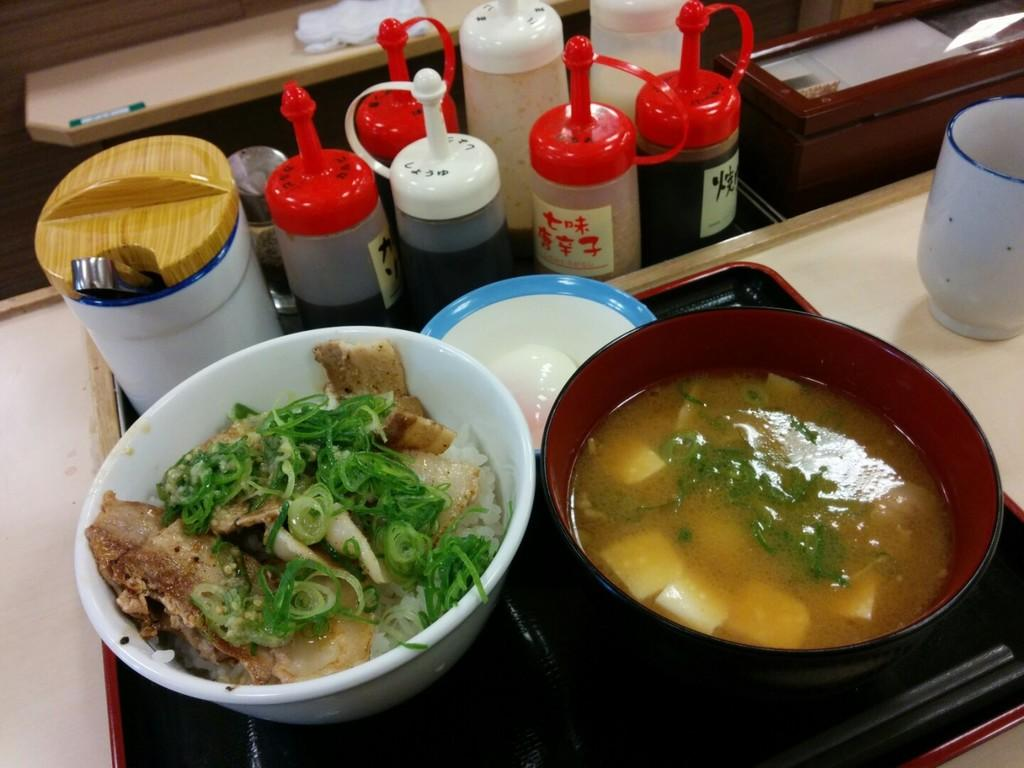What is in the bowl that is visible in the image? There are food items in a bowl in the image. Where is the bowl located in the image? The bowl is placed on a stove. What else can be seen in the image besides the bowl and stove? There are objects on a platform in front of the stove. What type of letters can be seen being written on the plantation in the image? There is no mention of letters or a plantation in the image; it features a bowl of food items on a stove with objects on a platform in front of it. 